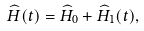<formula> <loc_0><loc_0><loc_500><loc_500>\widehat { H } ( t ) = \widehat { H } _ { 0 } + \widehat { H } _ { 1 } ( t ) ,</formula> 